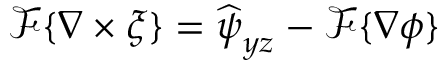Convert formula to latex. <formula><loc_0><loc_0><loc_500><loc_500>\mathcal { F } \{ \nabla \times \xi \} = \widehat { \psi } _ { y z } - \mathcal { F } \{ \nabla \phi \}</formula> 